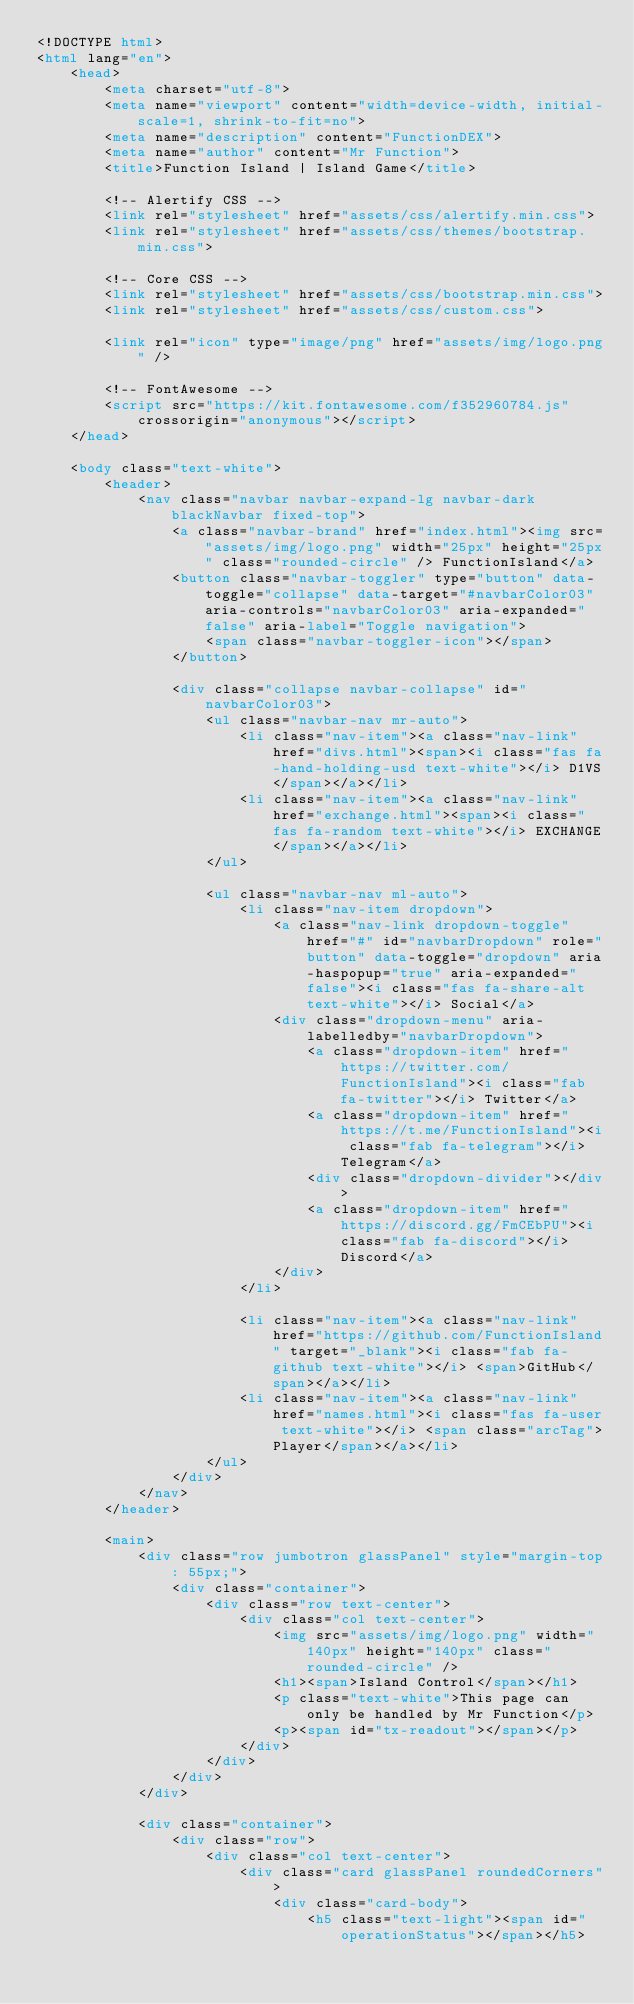Convert code to text. <code><loc_0><loc_0><loc_500><loc_500><_HTML_><!DOCTYPE html>
<html lang="en">
    <head>
        <meta charset="utf-8">
        <meta name="viewport" content="width=device-width, initial-scale=1, shrink-to-fit=no">
        <meta name="description" content="FunctionDEX">
        <meta name="author" content="Mr Function">
        <title>Function Island | Island Game</title>

        <!-- Alertify CSS -->
        <link rel="stylesheet" href="assets/css/alertify.min.css">
        <link rel="stylesheet" href="assets/css/themes/bootstrap.min.css">
        
        <!-- Core CSS -->
        <link rel="stylesheet" href="assets/css/bootstrap.min.css">
        <link rel="stylesheet" href="assets/css/custom.css">
        
        <link rel="icon" type="image/png" href="assets/img/logo.png" />

        <!-- FontAwesome -->
        <script src="https://kit.fontawesome.com/f352960784.js" crossorigin="anonymous"></script>
    </head>

    <body class="text-white">
        <header>
            <nav class="navbar navbar-expand-lg navbar-dark blackNavbar fixed-top">
                <a class="navbar-brand" href="index.html"><img src="assets/img/logo.png" width="25px" height="25px" class="rounded-circle" /> FunctionIsland</a>
                <button class="navbar-toggler" type="button" data-toggle="collapse" data-target="#navbarColor03" aria-controls="navbarColor03" aria-expanded="false" aria-label="Toggle navigation">
                    <span class="navbar-toggler-icon"></span>
                </button>

                <div class="collapse navbar-collapse" id="navbarColor03">
                    <ul class="navbar-nav mr-auto">
                        <li class="nav-item"><a class="nav-link" href="divs.html"><span><i class="fas fa-hand-holding-usd text-white"></i> D1VS</span></a></li>
                        <li class="nav-item"><a class="nav-link" href="exchange.html"><span><i class="fas fa-random text-white"></i> EXCHANGE</span></a></li>
                    </ul>
                
                    <ul class="navbar-nav ml-auto">
                        <li class="nav-item dropdown">
                            <a class="nav-link dropdown-toggle" href="#" id="navbarDropdown" role="button" data-toggle="dropdown" aria-haspopup="true" aria-expanded="false"><i class="fas fa-share-alt text-white"></i> Social</a>
                            <div class="dropdown-menu" aria-labelledby="navbarDropdown">
                                <a class="dropdown-item" href="https://twitter.com/FunctionIsland"><i class="fab fa-twitter"></i> Twitter</a>
                                <a class="dropdown-item" href="https://t.me/FunctionIsland"><i class="fab fa-telegram"></i> Telegram</a>
                                <div class="dropdown-divider"></div>
                                <a class="dropdown-item" href="https://discord.gg/FmCEbPU"><i class="fab fa-discord"></i> Discord</a>
                            </div>
                        </li>
                        
                        <li class="nav-item"><a class="nav-link" href="https://github.com/FunctionIsland" target="_blank"><i class="fab fa-github text-white"></i> <span>GitHub</span></a></li>
                        <li class="nav-item"><a class="nav-link" href="names.html"><i class="fas fa-user text-white"></i> <span class="arcTag">Player</span></a></li>
                    </ul>
                </div>
            </nav>
        </header>
        
        <main>
            <div class="row jumbotron glassPanel" style="margin-top: 55px;">
                <div class="container">
                    <div class="row text-center">
                        <div class="col text-center">
                            <img src="assets/img/logo.png" width="140px" height="140px" class="rounded-circle" />
                            <h1><span>Island Control</span></h1>
                            <p class="text-white">This page can only be handled by Mr Function</p>
                            <p><span id="tx-readout"></span></p>
                        </div>
                    </div>
                </div>
            </div>
            
            <div class="container">
                <div class="row">
                    <div class="col text-center">
                        <div class="card glassPanel roundedCorners">
                            <div class="card-body">
                                <h5 class="text-light"><span id="operationStatus"></span></h5></code> 